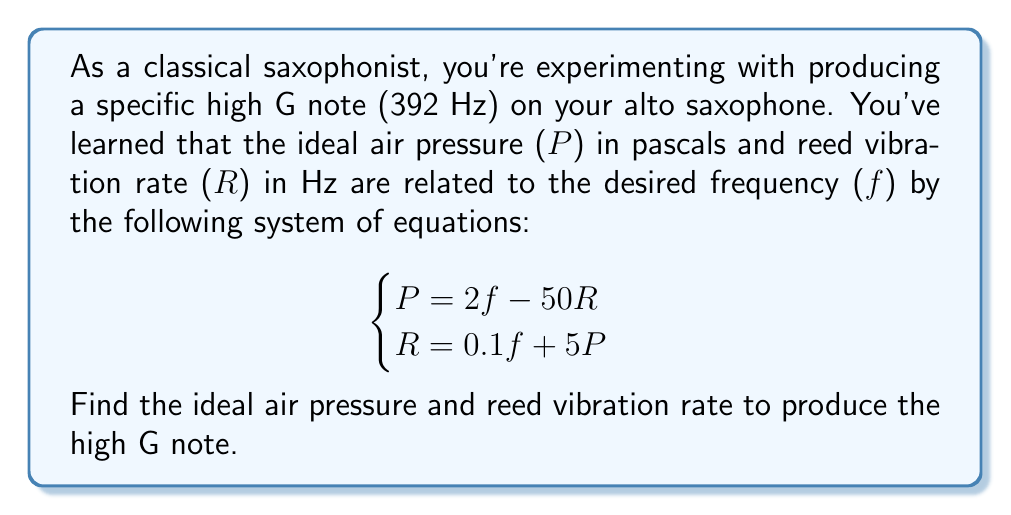Could you help me with this problem? Let's solve this system of equations step by step:

1) We know that f = 392 Hz (high G note). Let's substitute this into both equations:

   $$\begin{cases}
   P = 2(392) - 50R \\
   R = 0.1(392) + 5P
   \end{cases}$$

2) Simplify the first equation:
   $$P = 784 - 50R \quad (1)$$

3) Simplify the second equation:
   $$R = 39.2 + 5P \quad (2)$$

4) Now, let's substitute equation (2) into equation (1):
   $$P = 784 - 50(39.2 + 5P)$$

5) Distribute the -50:
   $$P = 784 - 1960 - 250P$$

6) Add 250P to both sides:
   $$251P = -1176$$

7) Divide both sides by 251:
   $$P = -4.6853 \approx -4.69 \text{ pascals}$$

8) Now that we have P, we can substitute it back into equation (2):
   $$R = 39.2 + 5(-4.69)$$
   $$R = 39.2 - 23.45 = 15.75 \text{ Hz}$$

Therefore, the ideal air pressure is approximately -4.69 pascals, and the ideal reed vibration rate is 15.75 Hz.
Answer: Air Pressure (P) ≈ -4.69 pascals
Reed Vibration Rate (R) ≈ 15.75 Hz 